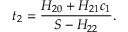<formula> <loc_0><loc_0><loc_500><loc_500>t _ { 2 } = \frac { H _ { 2 0 } + H _ { 2 1 } c _ { 1 } } { S - H _ { 2 2 } } .</formula> 